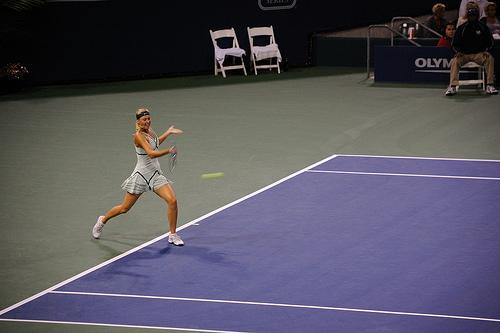How many people are there, and what are their distinct features?  There are two people: a woman in a tennis outfit with a headband and a man wearing a green shirt and beige pants sitting on a white chair. Describe the different leg and feet positions of the woman playing tennis. The woman has her knees bent, one foot on the blue court and the other on the gray cement. What is the relationship between the tennis court and the cement area? The tennis court is touching the cement area adjacent to it. Describe the appearance and position of the ball in the image. A yellow tennis ball is in the air with a green one slightly below it, both hit by a racket. Mention the color and pattern of the ground in the image. The ground is a blue and white tennis court that meets gray cement. List some of the objects found around the tennis court. folding chairs, towels, tennis balls, tennis racquet, ledge, soda, and rails Provide a brief description of the chairs and their accompanying items. There are two white folding chairs with towels laid on them, placed next to each other. Identify the hair color and style of the woman in the image. The woman has blonde hair which is pulled back into a ponytail. Explain the appearance and purpose of the woman's headwear. She is wearing a dark headband with white lettering, possibly to keep her hair in place while playing tennis. Find the activity a person is involved in by observing their attire and equipment.  A woman is playing tennis as she's wearing a tennis outfit and holding a tennis racquet. 